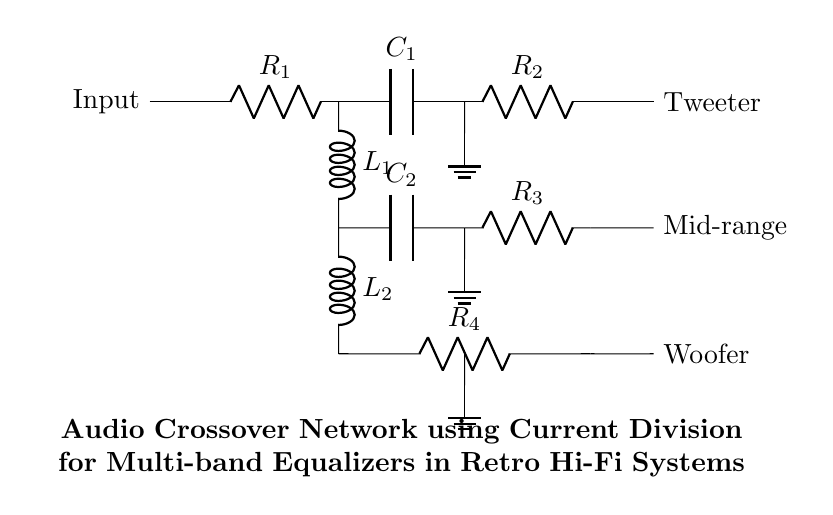What are the resistors in the circuit? The resistors in the circuit are R1, R2, R3, and R4, which are clearly labeled along the paths connecting different components.
Answer: R1, R2, R3, R4 What type of filter is connected to the tweeter? A high-pass filter is connected to the tweeter, as indicated by the capacitor C1 and the resistor R2 in series, allowing high-frequency signals to pass through.
Answer: High-pass filter How many capacitors are in the circuit? There are two capacitors in the circuit: C1 and C2, as shown in the paths that lead to the tweeter and mid-range speakers, respectively.
Answer: 2 What is the purpose of component L1? Component L1 is an inductor used in the mid-range filter; it stores energy in a magnetic field and allows specific frequencies to pass while blocking others.
Answer: Inductor for mid-range Which component is the woofer connected to? The woofer is connected to the low-pass filter, comprised of inductor L2 and resistor R4, allowing low-frequency sounds to be transmitted.
Answer: Low-pass filter How does current division occur in this circuit? Current division occurs as the input current splits at R1 into multiple branches: one leading to the high-pass filter and the others to the mid-range and low-pass filters. The different resistances control the current levels in each branch.
Answer: Through R1 branching 